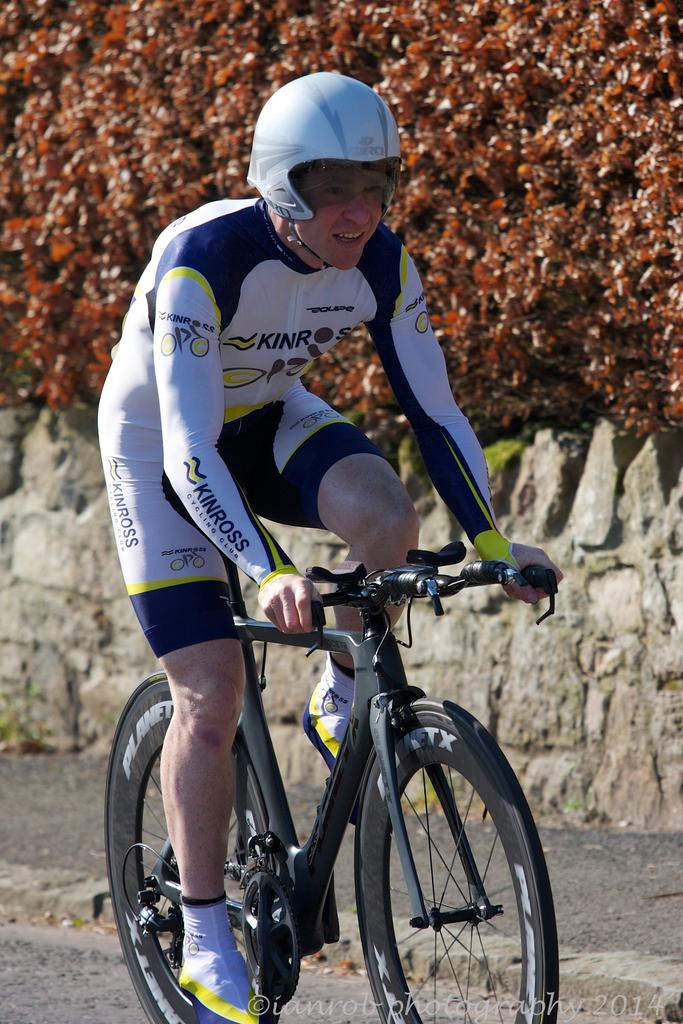What is the person in the image doing? The person is riding a bicycle in the image. What is the person wearing while riding the bicycle? The person is wearing clothes and a helmet on their head. What can be seen in the background of the image? There is a wall and a tree at the top of the image. What type of scarf is the person wearing while riding the bicycle in the image? There is no scarf visible in the image; the person is only wearing clothes and a helmet. What is the rail used for in the image? There is no rail present in the image; it features a person riding a bicycle, a wall, and a tree. 